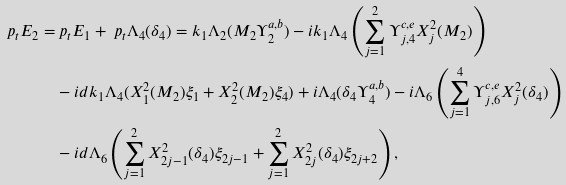Convert formula to latex. <formula><loc_0><loc_0><loc_500><loc_500>\ p _ { t } E _ { 2 } = & \ p _ { t } E _ { 1 } + \ p _ { t } \Lambda _ { 4 } ( \delta _ { 4 } ) = k _ { 1 } \Lambda _ { 2 } ( M _ { 2 } \Upsilon _ { 2 } ^ { a , b } ) - i k _ { 1 } \Lambda _ { 4 } \left ( \sum _ { j = 1 } ^ { 2 } \Upsilon _ { j , 4 } ^ { c , e } X _ { j } ^ { 2 } ( M _ { 2 } ) \right ) \\ & - i d k _ { 1 } \Lambda _ { 4 } ( X _ { 1 } ^ { 2 } ( M _ { 2 } ) \xi _ { 1 } + X _ { 2 } ^ { 2 } ( M _ { 2 } ) \xi _ { 4 } ) + i \Lambda _ { 4 } ( \delta _ { 4 } \Upsilon _ { 4 } ^ { a , b } ) - i \Lambda _ { 6 } \left ( \sum _ { j = 1 } ^ { 4 } \Upsilon _ { j , 6 } ^ { c , e } X _ { j } ^ { 2 } ( \delta _ { 4 } ) \right ) \\ & - i d \Lambda _ { 6 } \left ( \sum _ { j = 1 } ^ { 2 } X _ { 2 j - 1 } ^ { 2 } ( \delta _ { 4 } ) \xi _ { 2 j - 1 } + \sum _ { j = 1 } ^ { 2 } X _ { 2 j } ^ { 2 } ( \delta _ { 4 } ) \xi _ { 2 j + 2 } \right ) ,</formula> 